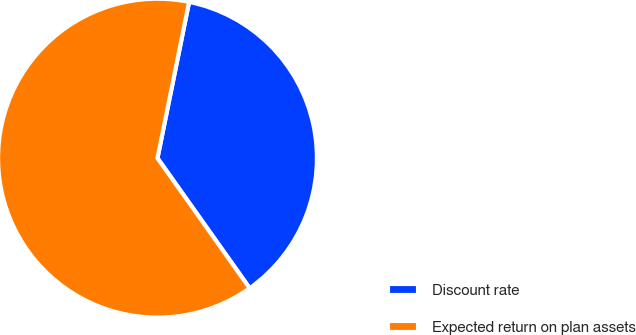<chart> <loc_0><loc_0><loc_500><loc_500><pie_chart><fcel>Discount rate<fcel>Expected return on plan assets<nl><fcel>37.01%<fcel>62.99%<nl></chart> 